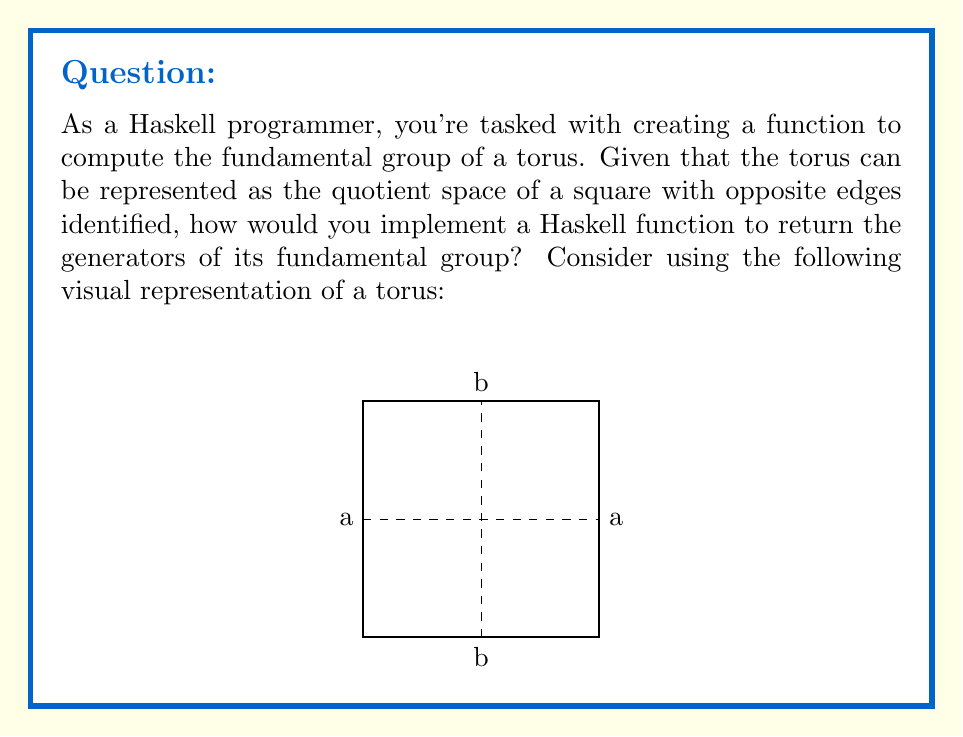Can you answer this question? To solve this problem, we need to understand the fundamental group of a torus and how to represent it in Haskell. Let's break it down step-by-step:

1. The fundamental group of a torus is isomorphic to $\mathbb{Z} \times \mathbb{Z}$, which means it has two generators.

2. These generators correspond to the two independent loops on the torus: one going around the "tube" (let's call it 'a') and one going through the "hole" (let's call it 'b').

3. In the square representation of the torus, these generators are represented by the horizontal and vertical paths connecting the identified edges.

4. In Haskell, we can represent these generators as strings or custom data types. For simplicity, let's use strings.

5. The function to compute the fundamental group should return a list of these generators.

6. Here's a possible implementation in Haskell:

```haskell
fundamentalGroupTorus :: [String]
fundamentalGroupTorus = ["a", "b"]
```

7. This function returns a list containing the two generators of the fundamental group of the torus.

8. It's important to note that this representation is simplified. In a more complex implementation, we might want to include information about how these generators commute (i.e., $ab = ba$ in the fundamental group of a torus).

9. For a general topological space, computing the fundamental group can be much more complex and may require more sophisticated algebraic topology techniques.
Answer: ["a", "b"] 